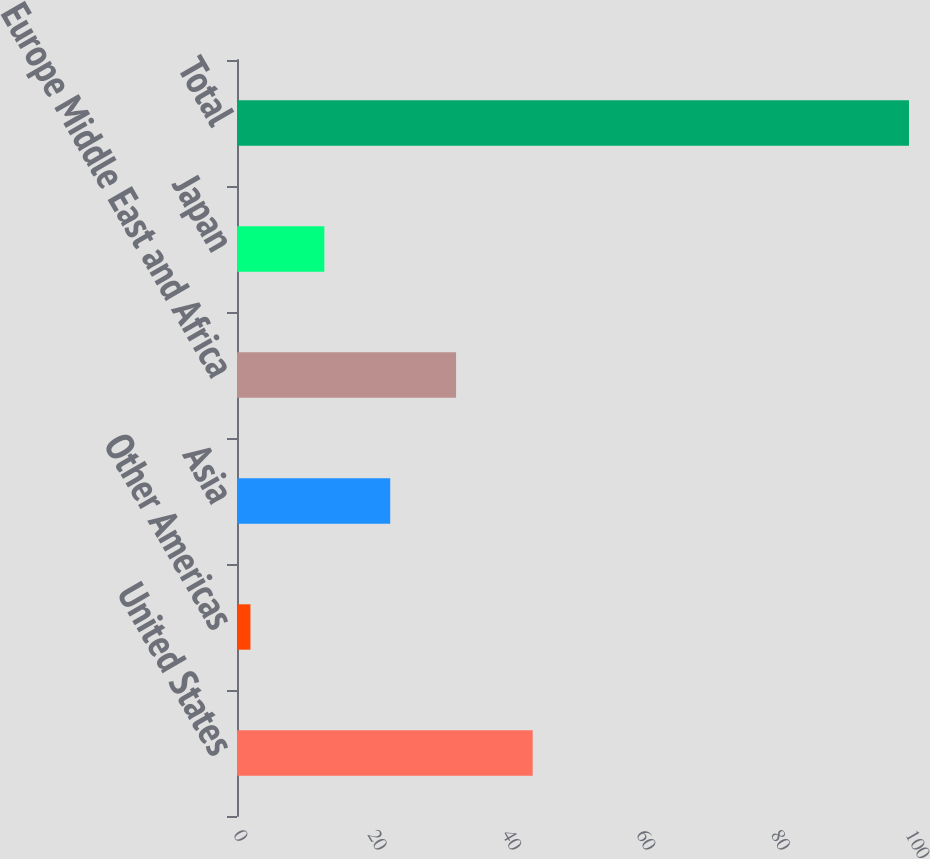<chart> <loc_0><loc_0><loc_500><loc_500><bar_chart><fcel>United States<fcel>Other Americas<fcel>Asia<fcel>Europe Middle East and Africa<fcel>Japan<fcel>Total<nl><fcel>44<fcel>2<fcel>22.8<fcel>32.6<fcel>13<fcel>100<nl></chart> 